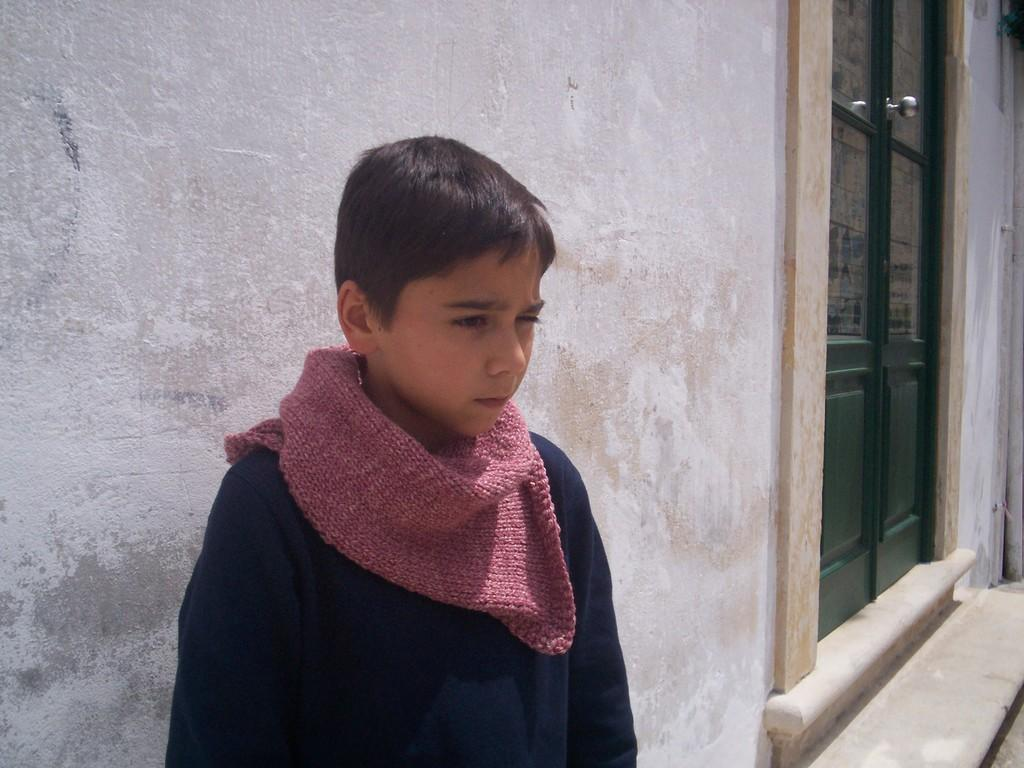Who is the main subject in the image? There is a boy in the image. Where is the boy positioned in relation to the wall? The boy is standing in front of a wall. What other architectural feature is visible in the image? There is a door beside the wall in the image. What type of rod is the boy using to knit wool in the image? There is no rod or wool present in the image, and the boy is not knitting. 